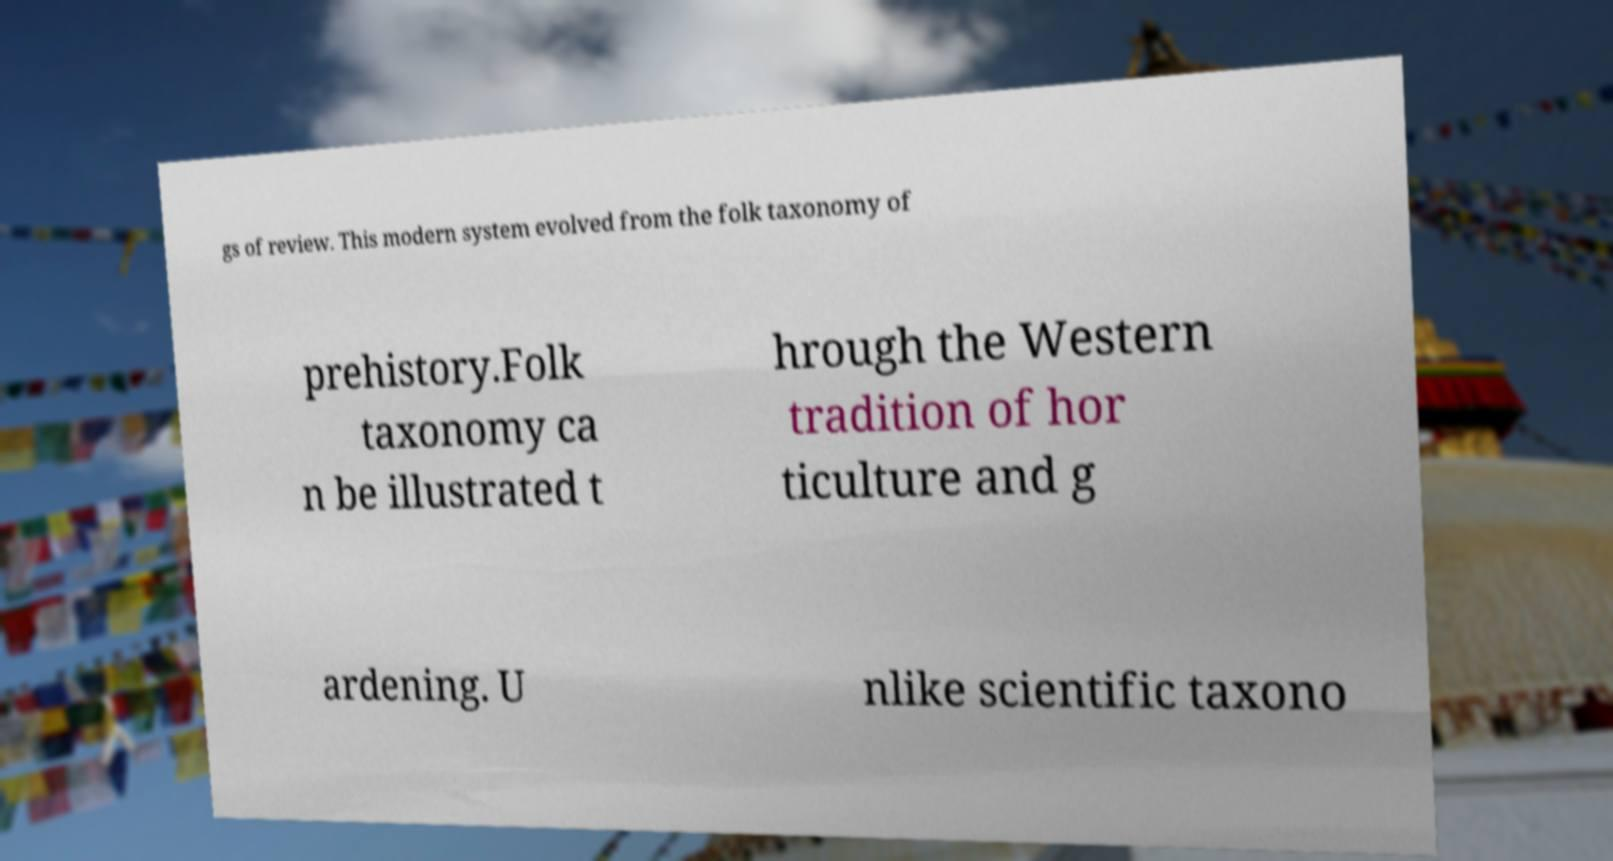Could you assist in decoding the text presented in this image and type it out clearly? gs of review. This modern system evolved from the folk taxonomy of prehistory.Folk taxonomy ca n be illustrated t hrough the Western tradition of hor ticulture and g ardening. U nlike scientific taxono 